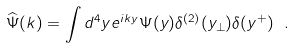Convert formula to latex. <formula><loc_0><loc_0><loc_500><loc_500>\widehat { \Psi } ( k ) = \int d ^ { 4 } y e ^ { i k y } \Psi ( y ) \delta ^ { ( 2 ) } ( { y } _ { \perp } ) \delta ( y ^ { + } ) \ .</formula> 